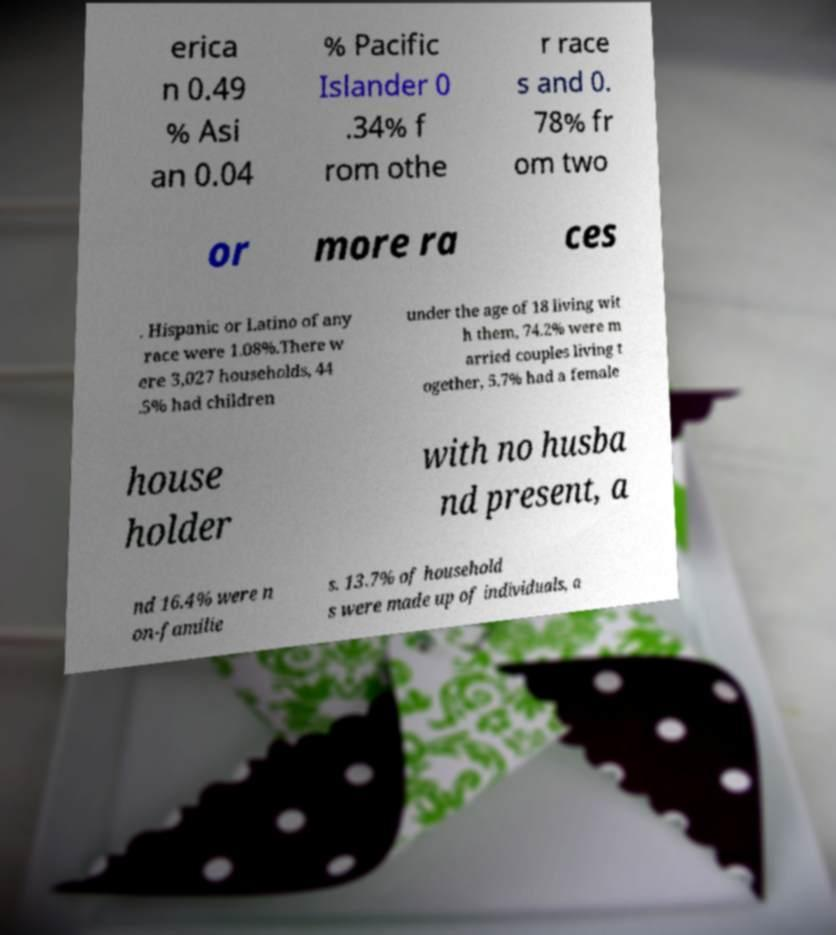What messages or text are displayed in this image? I need them in a readable, typed format. erica n 0.49 % Asi an 0.04 % Pacific Islander 0 .34% f rom othe r race s and 0. 78% fr om two or more ra ces . Hispanic or Latino of any race were 1.08%.There w ere 3,027 households, 44 .5% had children under the age of 18 living wit h them, 74.2% were m arried couples living t ogether, 5.7% had a female house holder with no husba nd present, a nd 16.4% were n on-familie s. 13.7% of household s were made up of individuals, a 